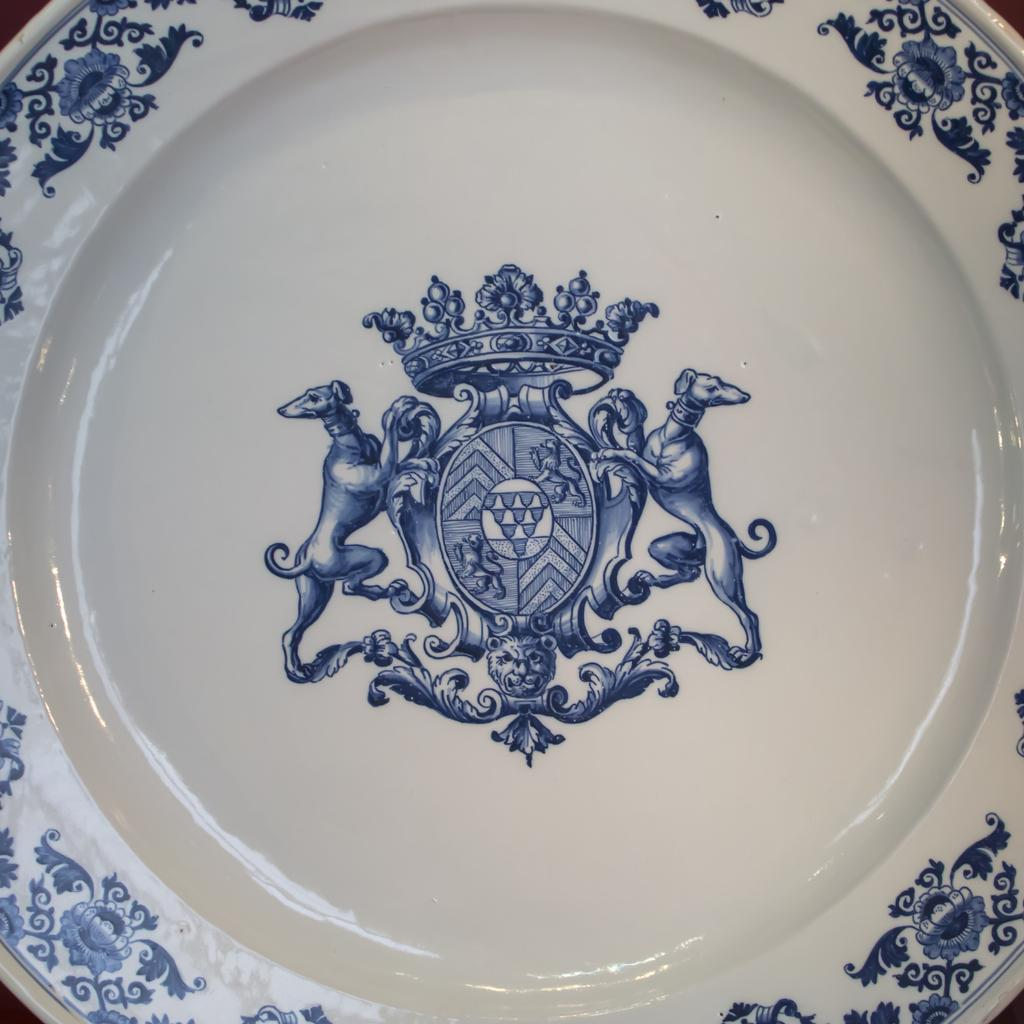What is present on the surface in the image? There is a plate in the image. Can you describe the position of the plate in the image? The plate is placed on a surface. What type of smoke can be seen coming from the plate in the image? There is no smoke present in the image; it only features a plate placed on a surface. 